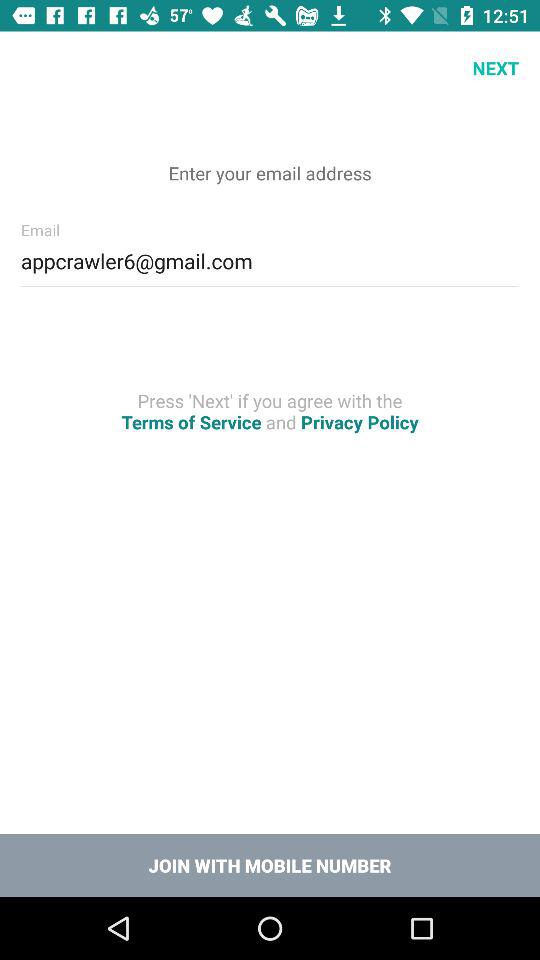What is the email address? The email address is appcrawler6@gmail.com. 